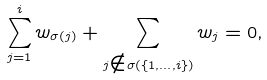<formula> <loc_0><loc_0><loc_500><loc_500>\sum _ { j = 1 } ^ { i } w _ { \sigma ( j ) } + \sum _ { j \notin \sigma ( \{ 1 , \dots , i \} ) } w _ { j } = 0 ,</formula> 